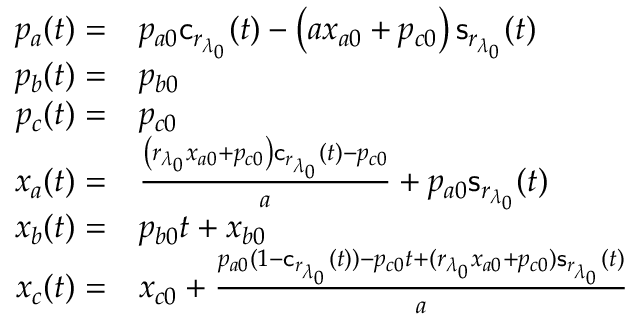<formula> <loc_0><loc_0><loc_500><loc_500>\begin{array} { r l } { p _ { a } ( t ) = } & { p _ { a 0 } c _ { r _ { \lambda _ { 0 } } } ( t ) - \left ( a x _ { a 0 } + p _ { c 0 } \right ) s _ { r _ { \lambda _ { 0 } } } ( t ) } \\ { p _ { b } ( t ) = } & { p _ { b 0 } } \\ { p _ { c } ( t ) = } & { p _ { c 0 } } \\ { x _ { a } ( t ) = } & { \frac { \left ( { r _ { \lambda _ { 0 } } } x _ { a 0 } + p _ { c 0 } \right ) c _ { r _ { \lambda _ { 0 } } } ( t ) - p _ { c 0 } } { a } + p _ { a 0 } s _ { r _ { \lambda _ { 0 } } } ( t ) } \\ { x _ { b } ( t ) = } & { p _ { b 0 } t + x _ { b 0 } } \\ { x _ { c } ( t ) = } & { x _ { c 0 } + \frac { p _ { a 0 } ( 1 - c _ { r _ { \lambda _ { 0 } } } ( t ) ) - p _ { c 0 } t + ( { r _ { \lambda _ { 0 } } } x _ { a 0 } + p _ { c 0 } ) s _ { r _ { \lambda _ { 0 } } } ( t ) } { a } } \end{array}</formula> 